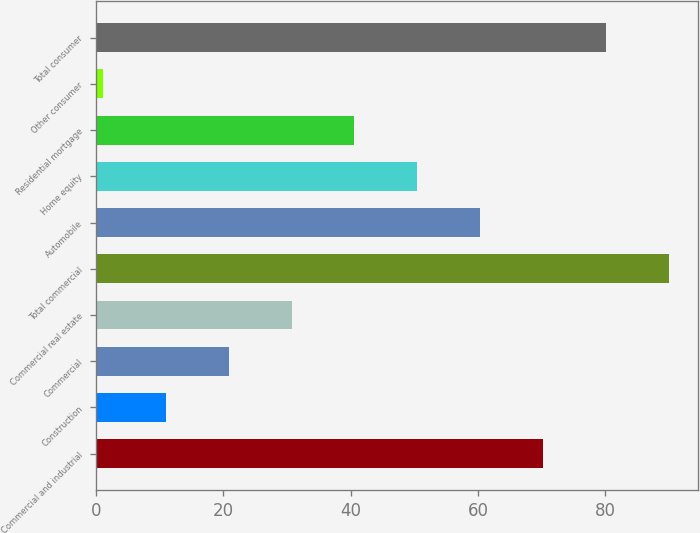Convert chart to OTSL. <chart><loc_0><loc_0><loc_500><loc_500><bar_chart><fcel>Commercial and industrial<fcel>Construction<fcel>Commercial<fcel>Commercial real estate<fcel>Total commercial<fcel>Automobile<fcel>Home equity<fcel>Residential mortgage<fcel>Other consumer<fcel>Total consumer<nl><fcel>70.3<fcel>10.9<fcel>20.8<fcel>30.7<fcel>90.1<fcel>60.4<fcel>50.5<fcel>40.6<fcel>1<fcel>80.2<nl></chart> 